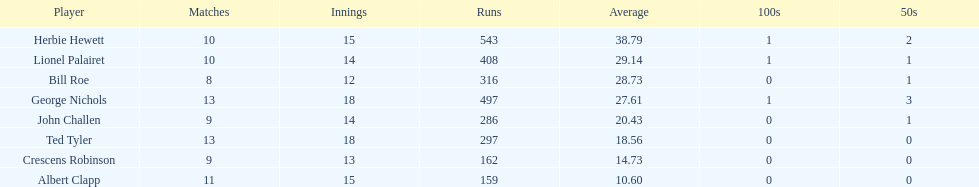In how many innings did albert clapp participate? 15. 